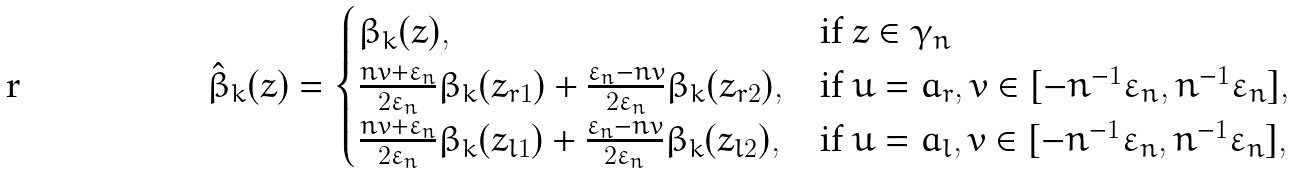Convert formula to latex. <formula><loc_0><loc_0><loc_500><loc_500>\hat { \beta } _ { k } ( z ) = \begin{cases} \beta _ { k } ( z ) , & \text {if} \ z \in \gamma _ { n } \\ \frac { n v + \varepsilon _ { n } } { 2 \varepsilon _ { n } } \beta _ { k } ( z _ { r 1 } ) + \frac { \varepsilon _ { n } - n v } { 2 \varepsilon _ { n } } \beta _ { k } ( z _ { r 2 } ) , & \text {if} \ u = a _ { r } , v \in [ - n ^ { - 1 } \varepsilon _ { n } , n ^ { - 1 } \varepsilon _ { n } ] , \\ \frac { n v + \varepsilon _ { n } } { 2 \varepsilon _ { n } } \beta _ { k } ( z _ { l 1 } ) + \frac { \varepsilon _ { n } - n v } { 2 \varepsilon _ { n } } \beta _ { k } ( z _ { l 2 } ) , & \text {if} \ u = a _ { l } , v \in [ - n ^ { - 1 } \varepsilon _ { n } , n ^ { - 1 } \varepsilon _ { n } ] , \end{cases}</formula> 